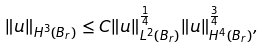<formula> <loc_0><loc_0><loc_500><loc_500>\| u \| _ { H ^ { 3 } ( B _ { r } ) } \leq C \| u \| _ { L ^ { 2 } ( B _ { r } ) } ^ { \frac { 1 } { 4 } } \| u \| _ { H ^ { 4 } ( B _ { r } ) } ^ { \frac { 3 } { 4 } } ,</formula> 